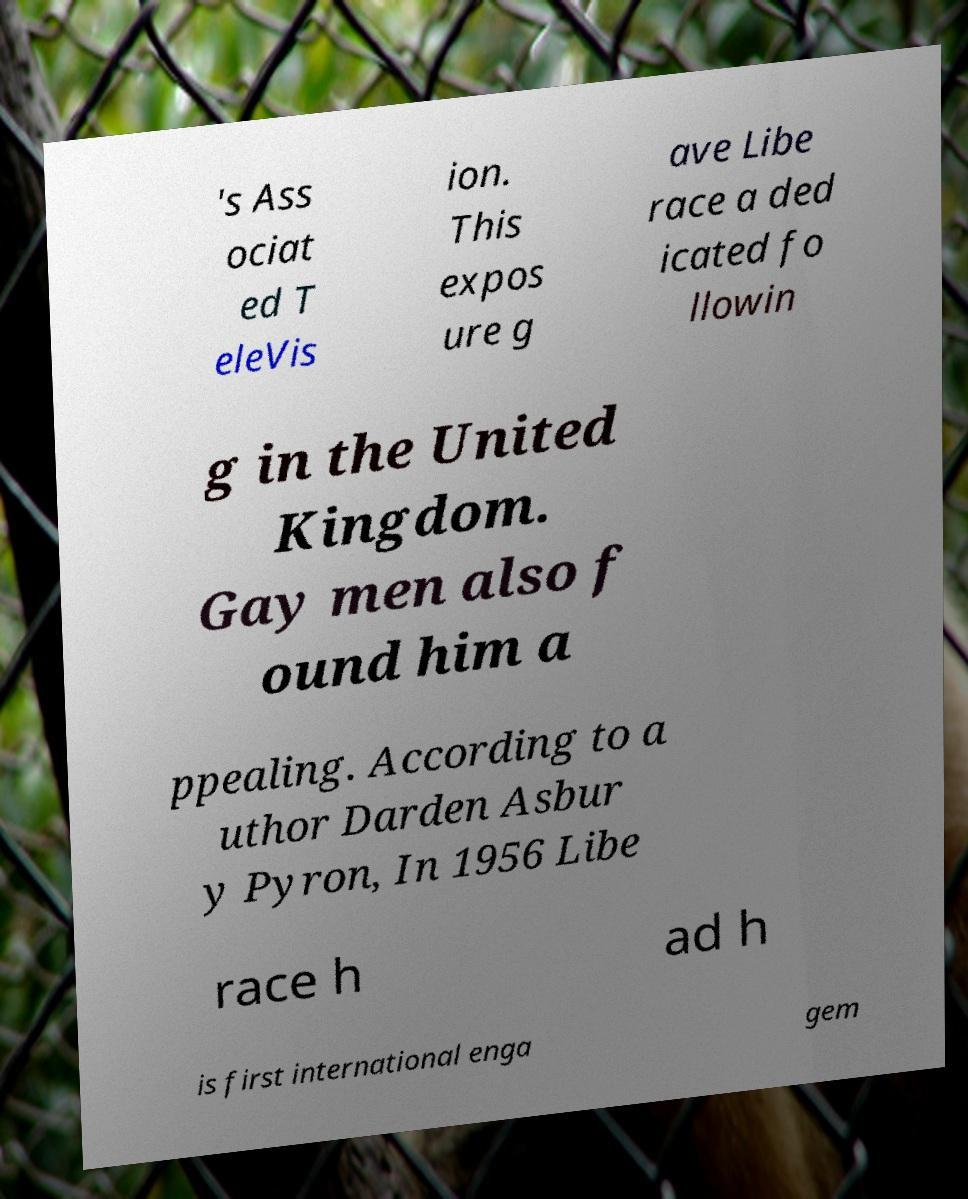Can you read and provide the text displayed in the image?This photo seems to have some interesting text. Can you extract and type it out for me? 's Ass ociat ed T eleVis ion. This expos ure g ave Libe race a ded icated fo llowin g in the United Kingdom. Gay men also f ound him a ppealing. According to a uthor Darden Asbur y Pyron, In 1956 Libe race h ad h is first international enga gem 